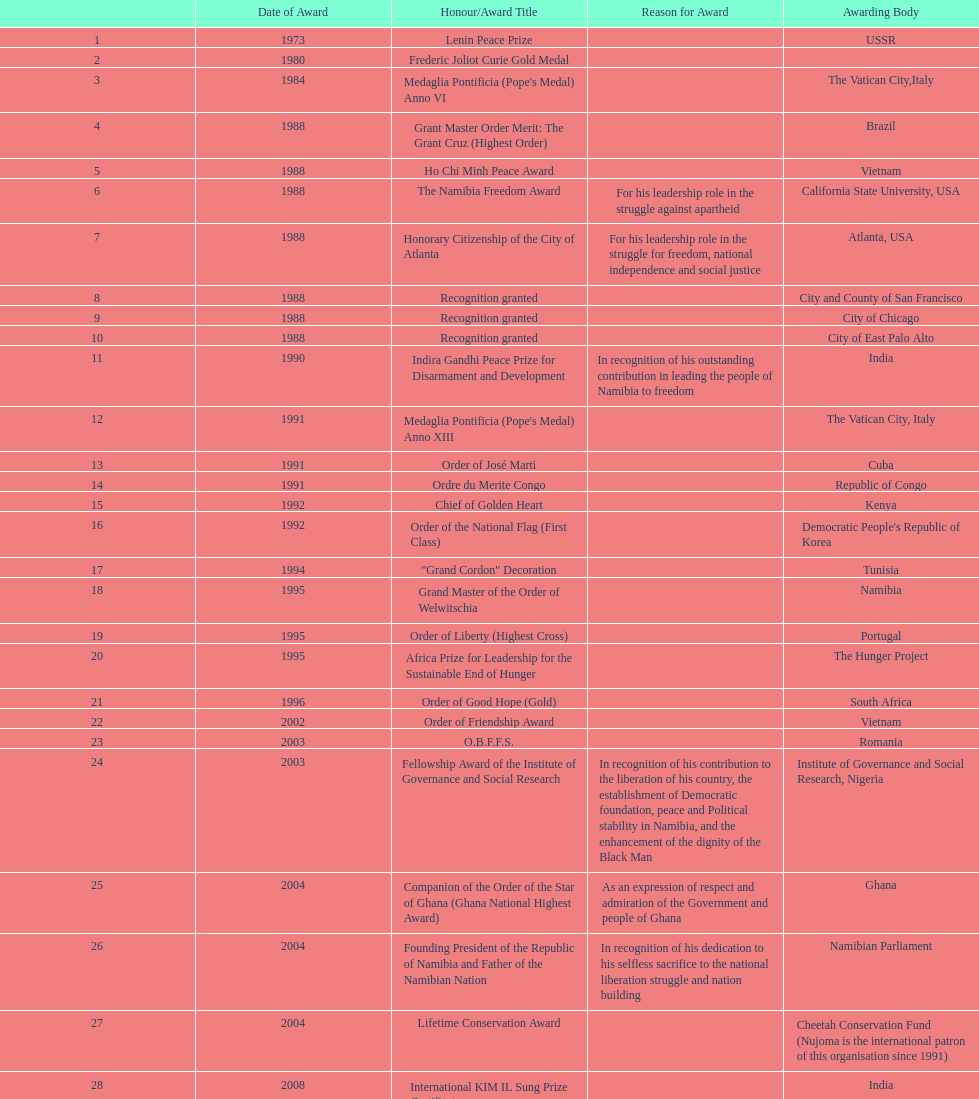What is the complete tally of awards that nujoma earned? 29. 